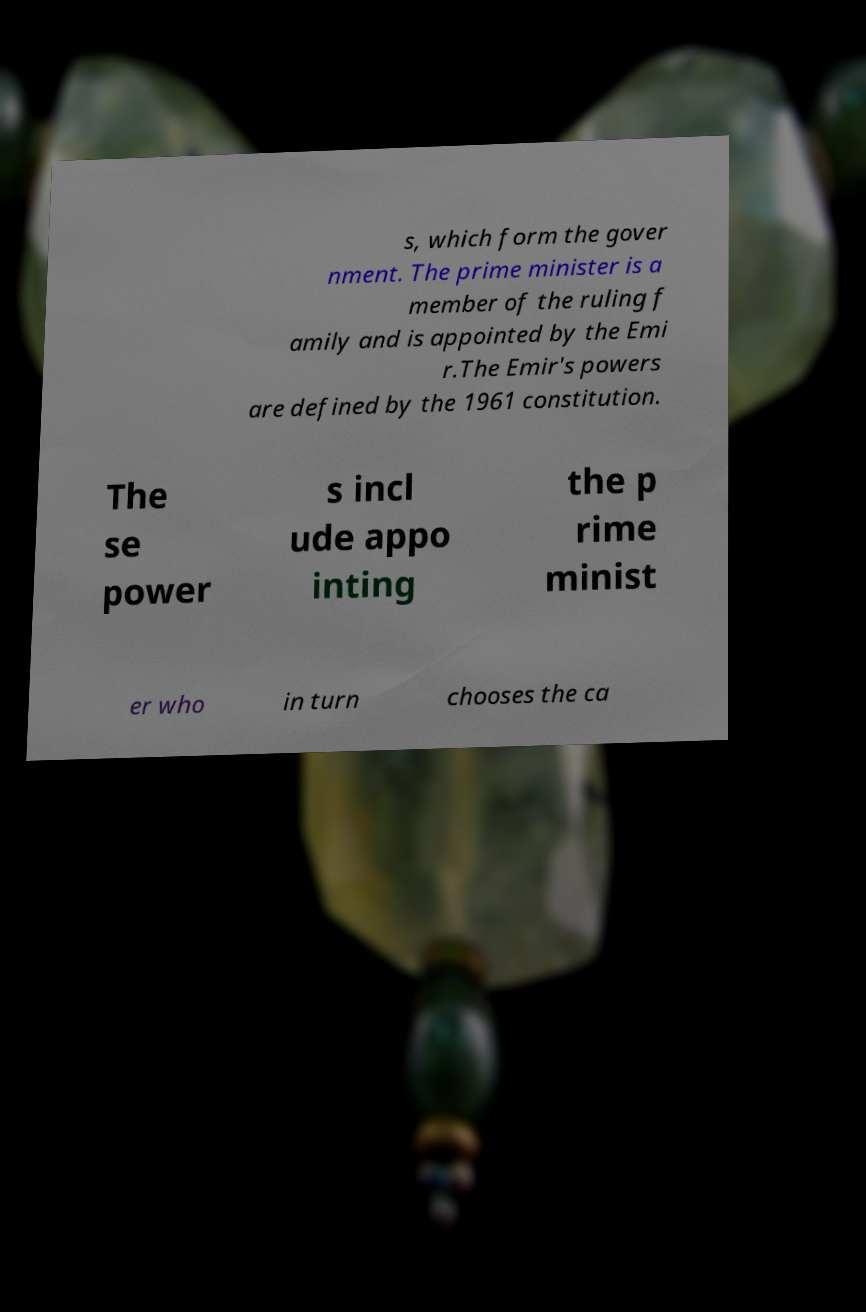Please identify and transcribe the text found in this image. s, which form the gover nment. The prime minister is a member of the ruling f amily and is appointed by the Emi r.The Emir's powers are defined by the 1961 constitution. The se power s incl ude appo inting the p rime minist er who in turn chooses the ca 